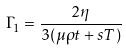<formula> <loc_0><loc_0><loc_500><loc_500>\Gamma _ { 1 } = \frac { 2 \eta } { 3 ( \mu \rho t + s T ) }</formula> 